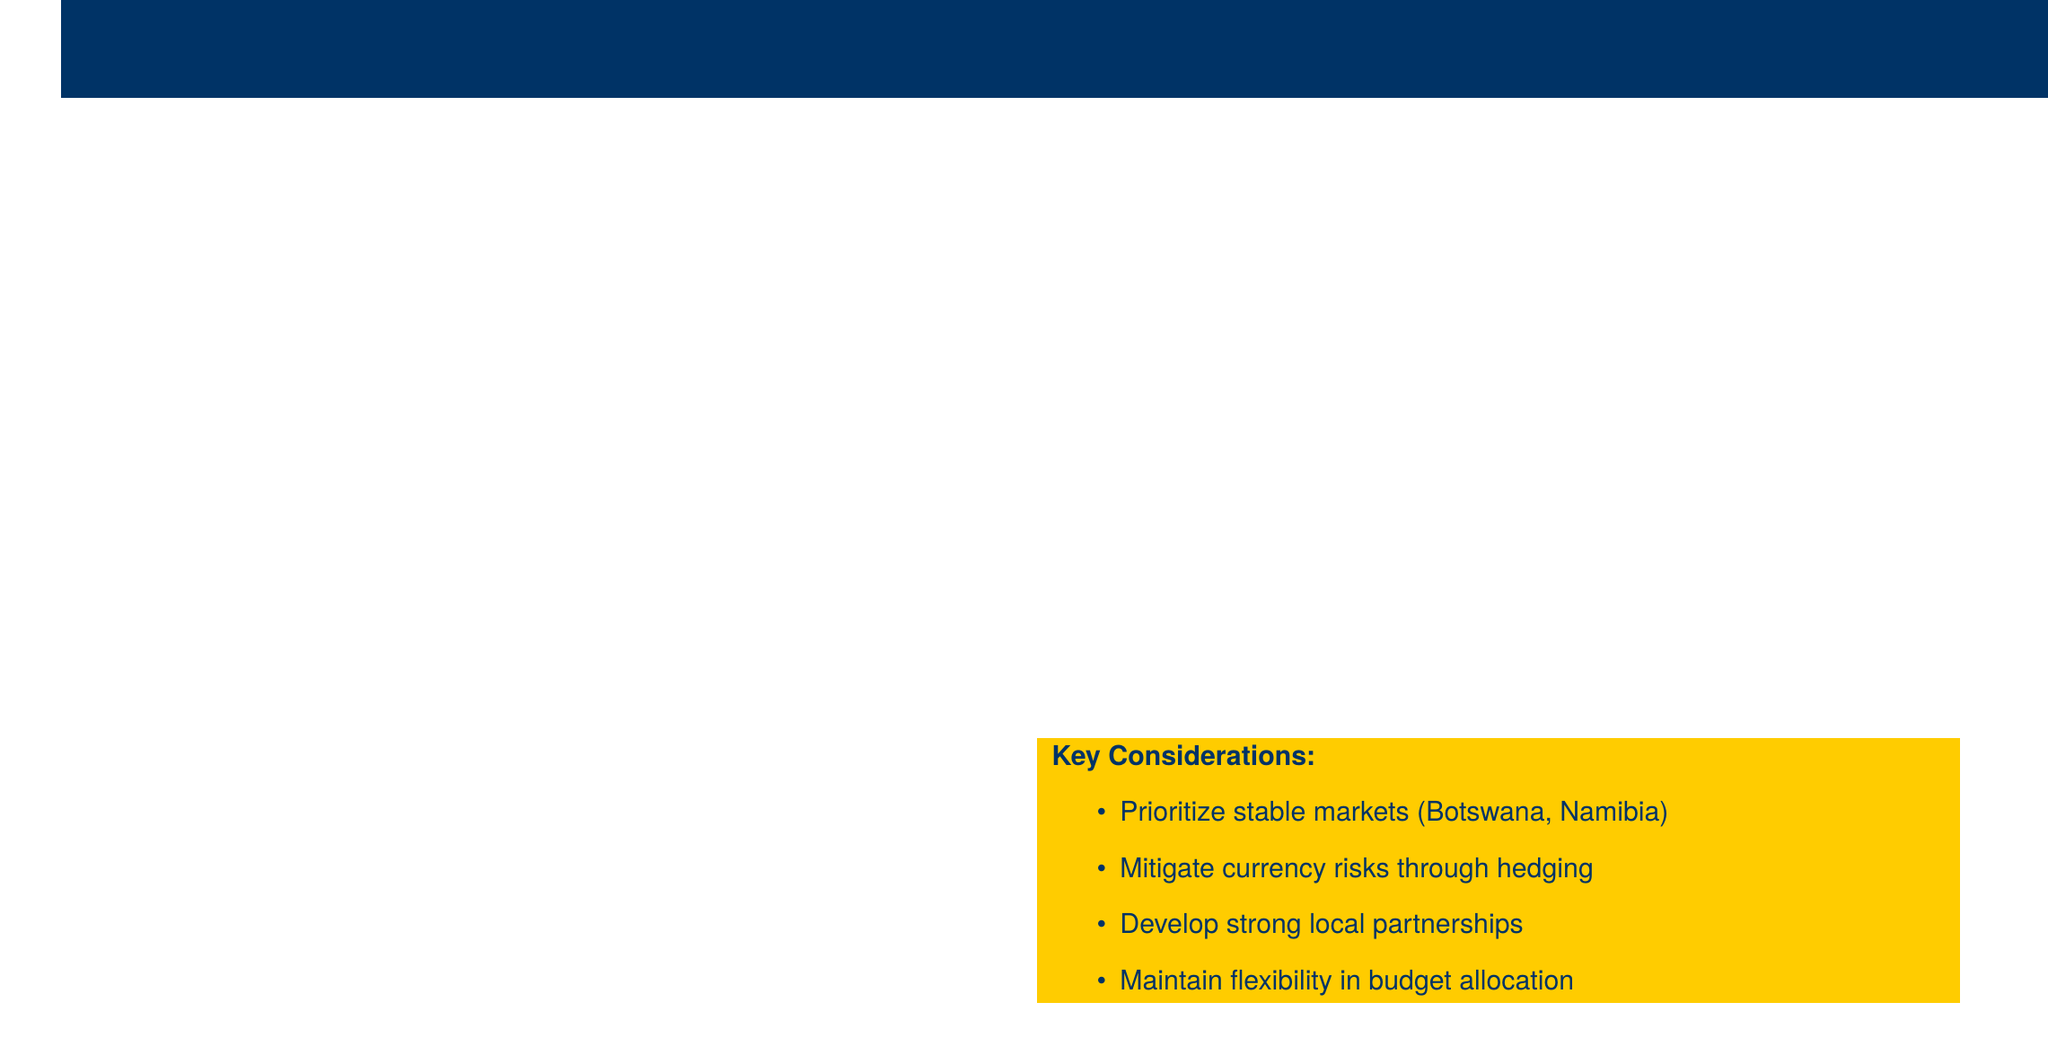What is the total projected budget? The total projected budget is stated in the budget overview section of the document.
Answer: $15 million What are the target countries for expansion? The target countries are listed in the budget overview section.
Answer: Botswana, Namibia, Zambia What is the initial setup cost in Zambia? The initial setup cost for Zambia is mentioned in the market entry costs table.
Answer: $1.5 million What is the annual staffing cost? The annual staffing cost is provided in the operational costs section.
Answer: $2.5 million What is the risk assessment level for political instability in Botswana? The risk assessment level for political instability in Botswana is detailed in the risk assessment table.
Answer: Low Which country has high economic volatility risk? The economic volatility risks are noted in the risk assessment table.
Answer: Zambia What is the contingency fund amount? The amount for the contingency fund is indicated in the document.
Answer: $1.5 million What type of risks are associated with currency fluctuations? The document specifies the risks related to currency fluctuations in the currency risks section.
Answer: High Who is a potential partner in Botswana? The potential partners are listed under the potential partners section.
Answer: Botswana Development Corporation 